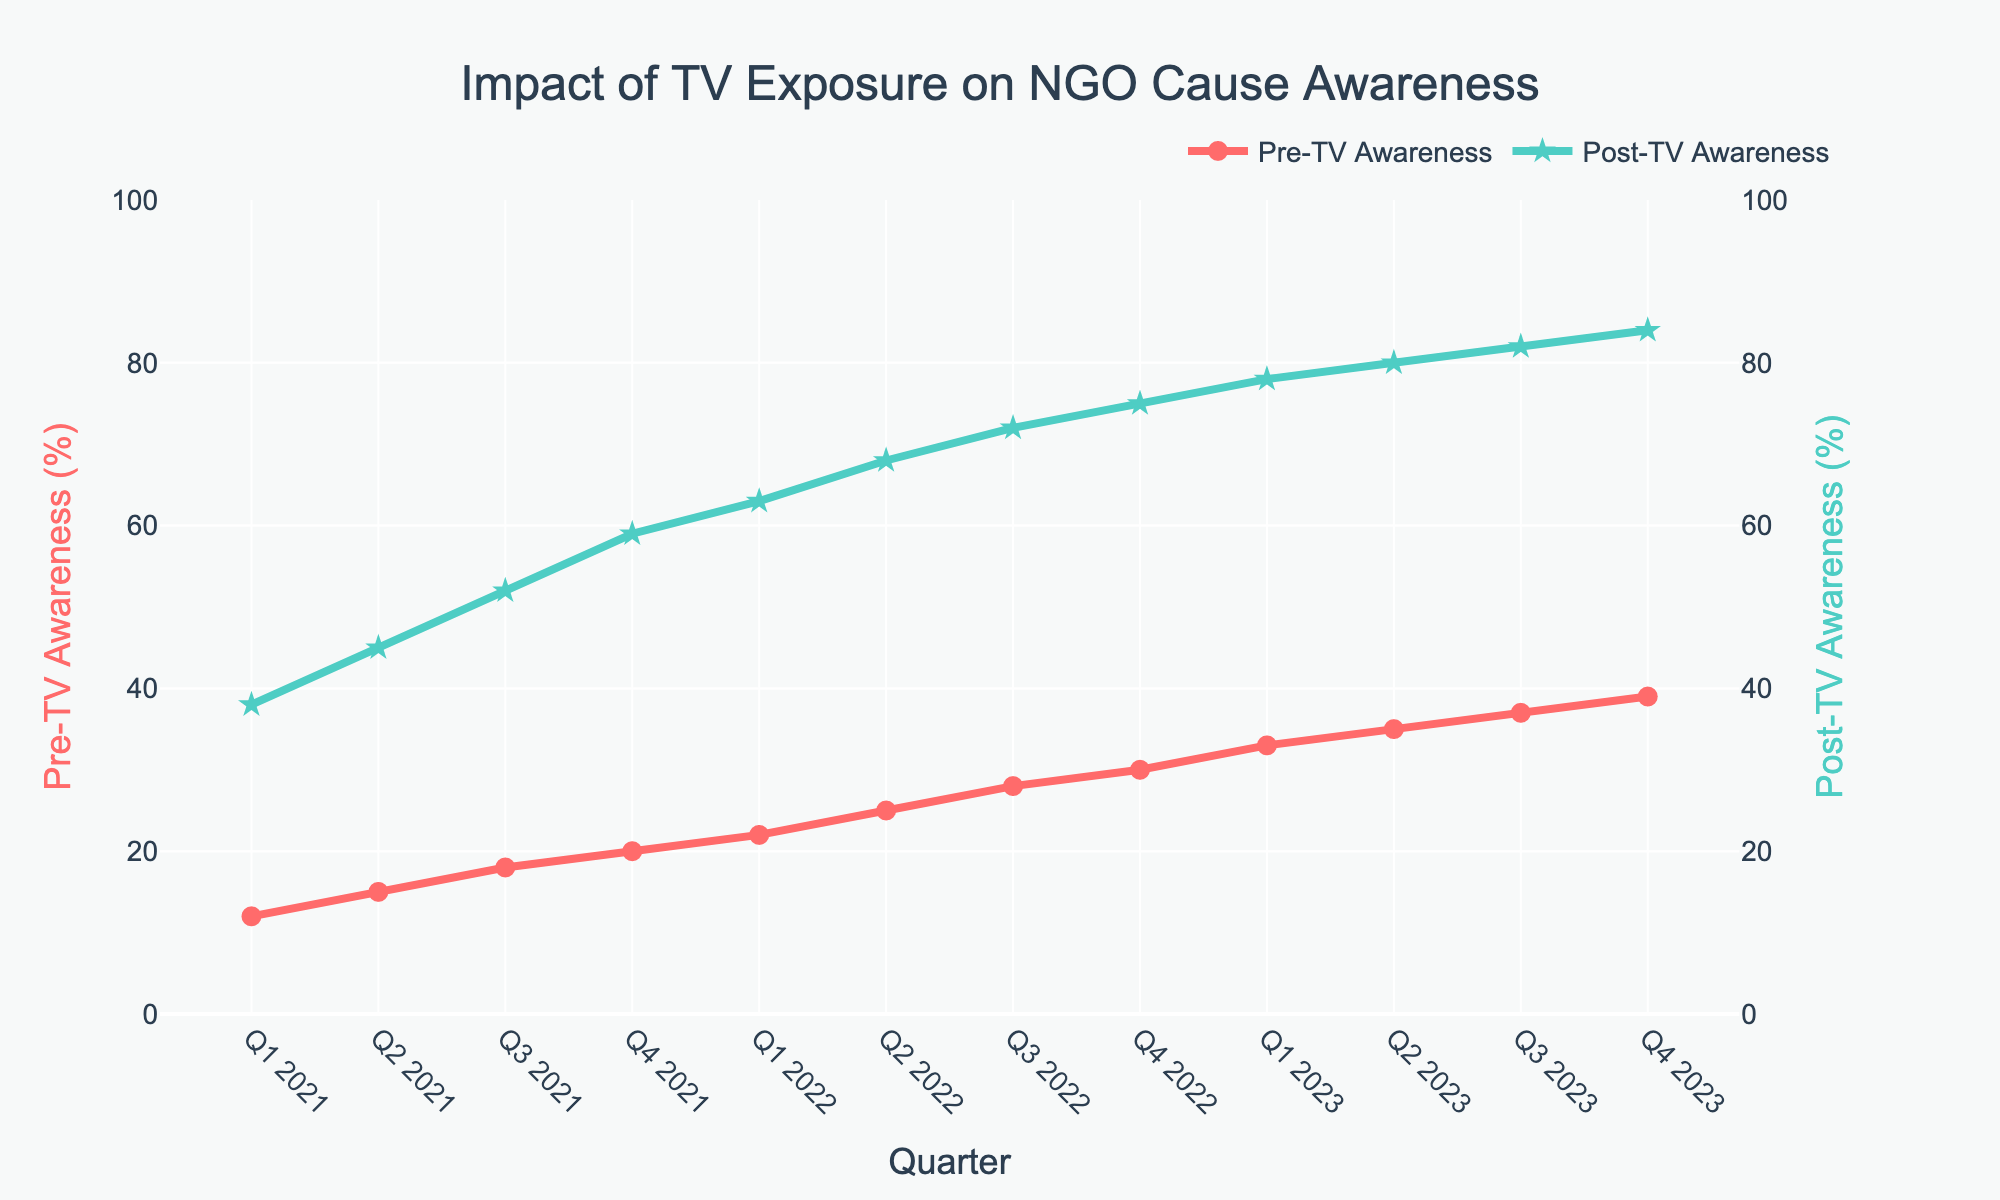What's the difference in post-TV awareness levels between Q1 2021 and Q4 2021? To find the difference, look at the post-TV awareness levels for Q1 2021 and Q4 2021. Subtract the value of Q1 2021 (38%) from Q4 2021 (59%): 59% - 38% = 21%
Answer: 21% Which quarter shows the highest pre-TV awareness? To determine this, compare the pre-TV awareness values across all quarters listed. The highest value is at Q4 2023 with 39% pre-TV awareness
Answer: Q4 2023 On average, how much did pre-TV awareness increase per quarter from Q1 2021 to Q4 2023? First, find the difference in pre-TV awareness between Q4 2023 (39%) and Q1 2021 (12%), which is 27%. Then, divide by the number of quarters (12): 27% / 12 = 2.25% on average per quarter
Answer: 2.25% What is the visual difference between the markers used for pre-TV and post-TV awareness? The markers for pre-TV awareness are circles, and the markers for post-TV awareness are stars
Answer: Circles vs. Stars How many quarters did it take for pre-TV awareness to go from 12% to over 30%? Look at the data points from Q1 2021 to Q4 2022. Pre-TV awareness goes from 12% to 30% between these quarters, which is 8 quarters.
Answer: 8 quarters What's the average post-TV awareness across all quarters shown? Sum all post-TV awareness percentages: 38 + 45 + 52 + 59 + 63 + 68 + 72 + 75 + 78 + 80 + 82 + 84 = 796. Divide by the number of quarters (12): 796 / 12 = 66.33%
Answer: 66.33% Is there any quarter where post-TV awareness is less than 50%? A quick glance shows that the first three quarters (Q1 2021 - Q3 2021) have post-TV awareness percentages of 38%, 45%, and 52%. Only Q1 2021 and Q2 2021 have values less than 50%
Answer: Yes, Q1 2021 and Q2 2021 Which quarter had the smallest increase in post-TV awareness compared to its previous quarter? Check the differences for post-TV awareness between each consecutive quarter. The smallest increase is from Q3 2023 (82%) to Q4 2023 (84%), which is an increase of 2%
Answer: Q3 2023 to Q4 2023 By how much did post-TV awareness improve on average per quarter from Q1 2021 to Q4 2023? The difference from Q1 2021 (38%) to Q4 2023 (84%) is 46%. Divide this by the number of quarters, which is 12: 46% / 12 = approximately 3.83% per quarter
Answer: 3.83% What is the visual trend of pre-TV and post-TV awareness from Q1 2021 to Q4 2023? Both pre-TV and post-TV awareness levels show an increasing trend. However, post-TV awareness increases at a higher rate compared to pre-TV awareness
Answer: Increasing trend 